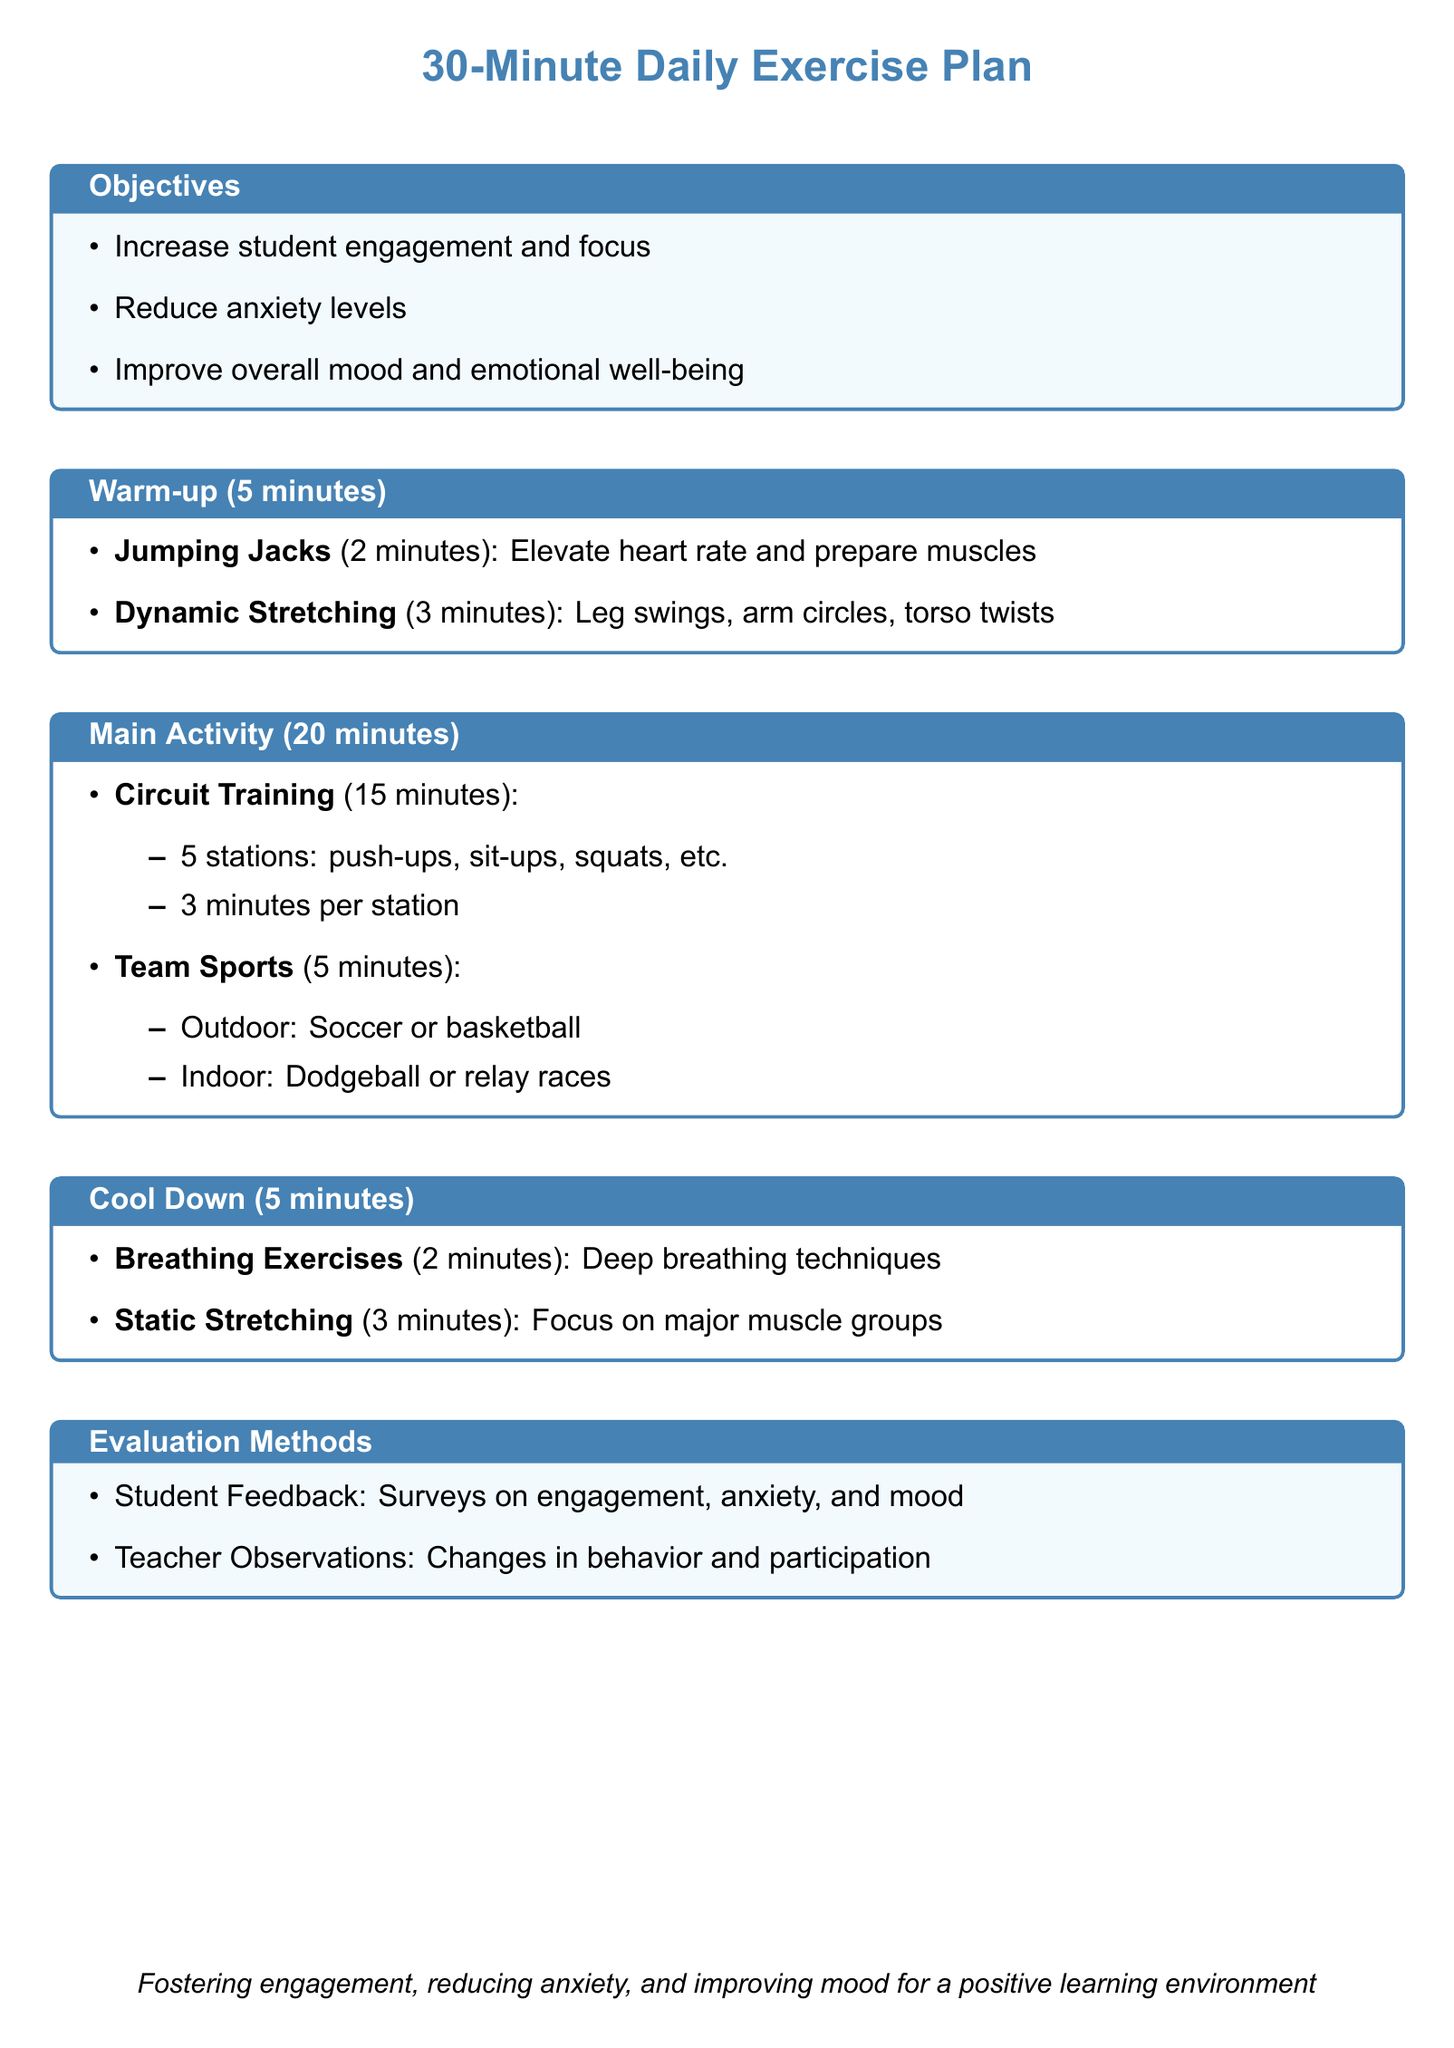What is the total duration of the exercise plan? The total duration is specified in the document as 30 minutes, consisting of warm-up, main activity, and cool down.
Answer: 30 minutes How long is the warm-up segment? The warm-up segment is a specific part of the exercise plan detailed in the document, which lasts for 5 minutes.
Answer: 5 minutes What is one main objective of the exercise plan? The document lists three objectives, and one of them is to reduce anxiety levels among students.
Answer: Reduce anxiety levels How many stations are included in the Circuit Training? The document specifically mentions there are 5 stations in the Circuit Training section for the main activity.
Answer: 5 stations What type of breathing exercises are included in the Cool Down? The document refers to a specific activity under the cool down that focuses on deep breathing techniques.
Answer: Deep breathing techniques What is one method of evaluation mentioned in the document? The document includes methods of evaluation, specifically mentioning student feedback gathered through surveys.
Answer: Student Feedback How long is the Main Activity section of the exercise plan? The length of the Main Activity section is provided in the document, indicating it lasts for 20 minutes.
Answer: 20 minutes What is the purpose of the cool-down activities? The document does not state a single purpose but implies that cool down activities help in relaxation and recovery after intense physical activity.
Answer: Relaxation and recovery What physical activity is suggested for the Team Sports portion? The document lists several options, indicating that soccer or basketball can be played for the Team Sports section during the main activity.
Answer: Soccer or basketball 